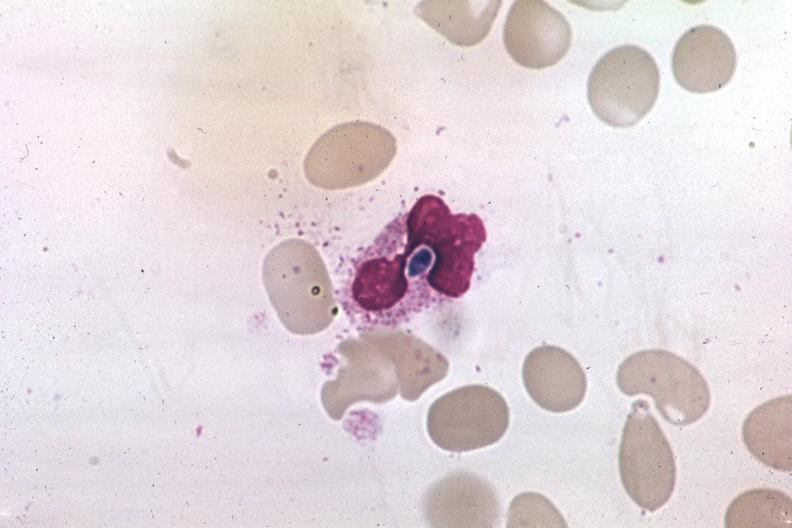s hematologic present?
Answer the question using a single word or phrase. Yes 